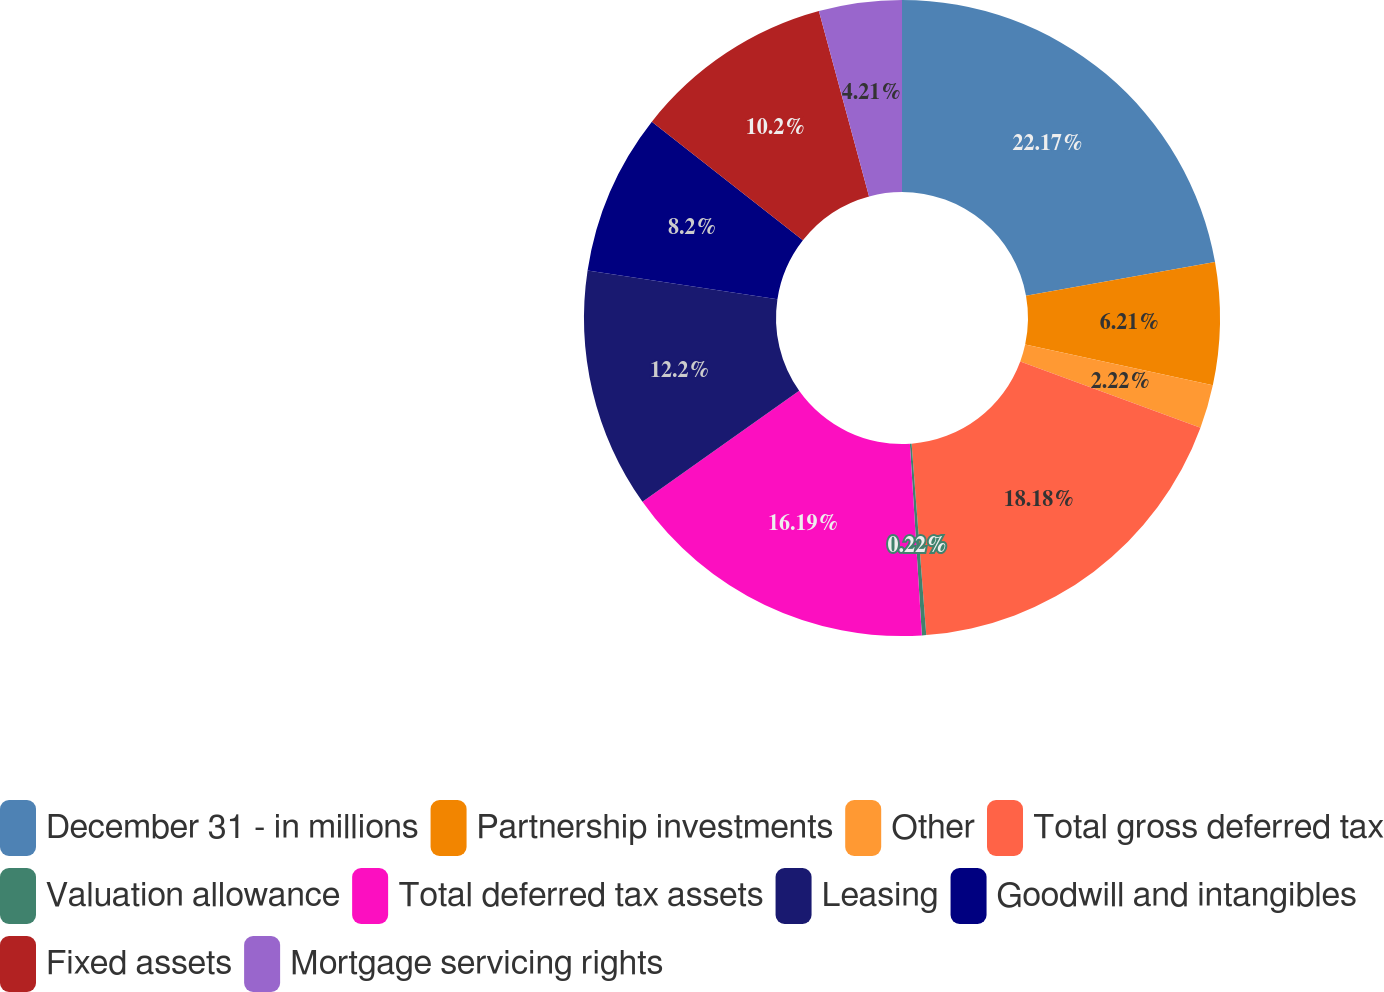Convert chart. <chart><loc_0><loc_0><loc_500><loc_500><pie_chart><fcel>December 31 - in millions<fcel>Partnership investments<fcel>Other<fcel>Total gross deferred tax<fcel>Valuation allowance<fcel>Total deferred tax assets<fcel>Leasing<fcel>Goodwill and intangibles<fcel>Fixed assets<fcel>Mortgage servicing rights<nl><fcel>22.18%<fcel>6.21%<fcel>2.22%<fcel>18.18%<fcel>0.22%<fcel>16.19%<fcel>12.2%<fcel>8.2%<fcel>10.2%<fcel>4.21%<nl></chart> 